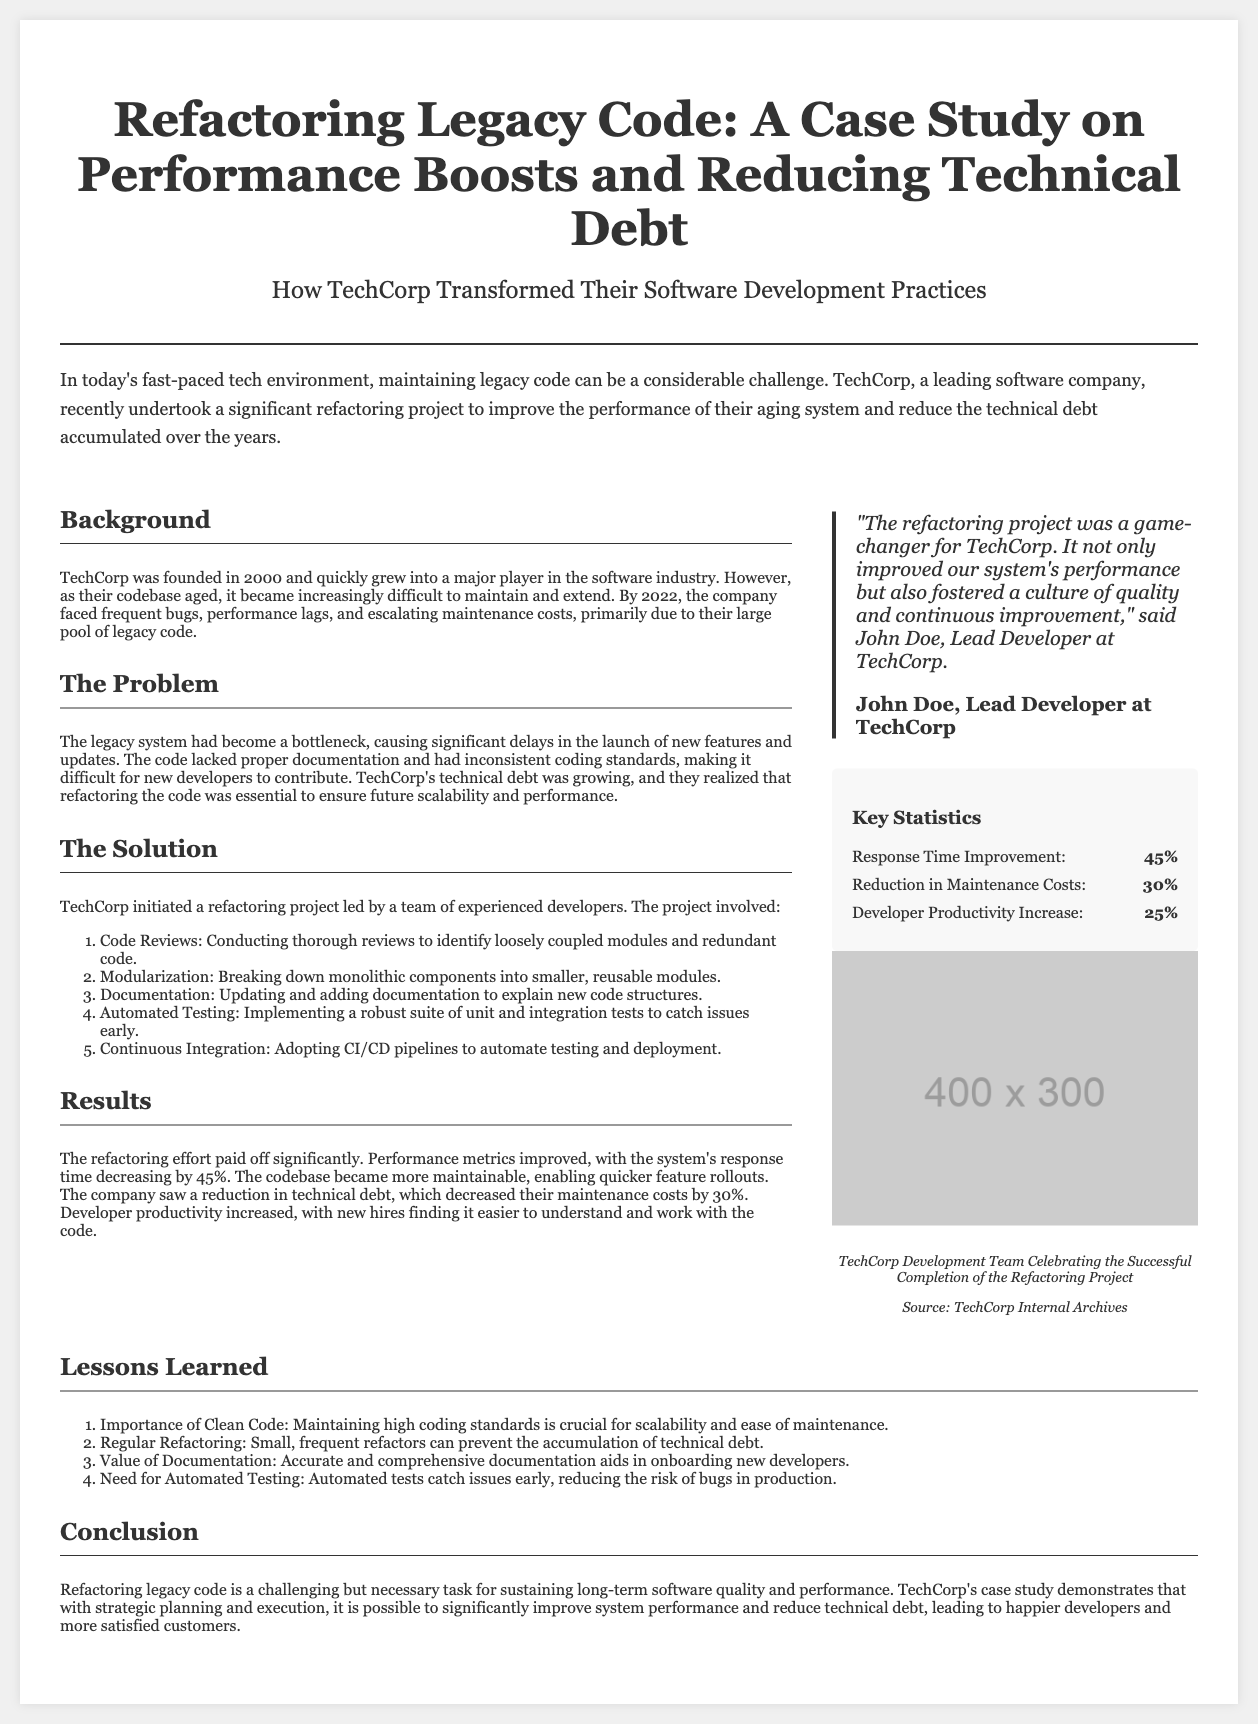What was the response time improvement percentage? The document states that the system's response time decreased by 45%.
Answer: 45% What year was TechCorp founded? The founding year of TechCorp is mentioned as 2000.
Answer: 2000 What is one major problem TechCorp faced with their legacy code? The document describes the legacy system as causing significant delays in launching new features.
Answer: Delays What is the reduction in maintenance costs after refactoring? The text specifies that maintenance costs decreased by 30%.
Answer: 30% Who is the Lead Developer at TechCorp? The document names John Doe as the Lead Developer.
Answer: John Doe What approach did TechCorp take in their refactoring project? The project involved conducting thorough code reviews to improve code quality.
Answer: Code Reviews What percentage increase did developer productivity see? The document reports a 25% increase in developer productivity.
Answer: 25% What is one lesson learned from the refactoring project? The document highlights the importance of clean code as a crucial lesson learned.
Answer: Clean Code What does CI/CD stand for? The abbreviation CI/CD stands for Continuous Integration and Continuous Deployment.
Answer: Continuous Integration and Continuous Deployment 